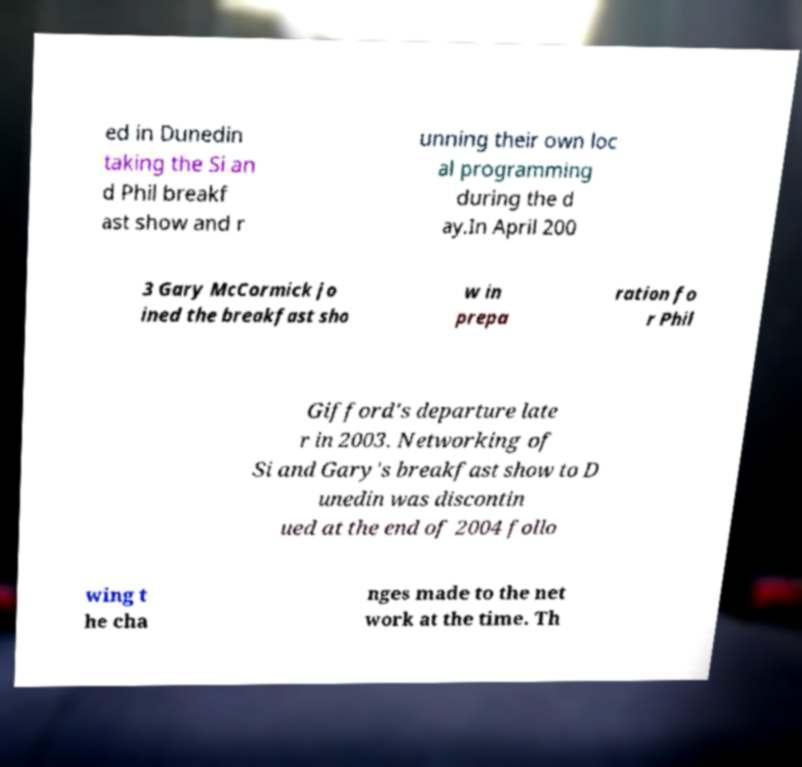What messages or text are displayed in this image? I need them in a readable, typed format. ed in Dunedin taking the Si an d Phil breakf ast show and r unning their own loc al programming during the d ay.In April 200 3 Gary McCormick jo ined the breakfast sho w in prepa ration fo r Phil Gifford's departure late r in 2003. Networking of Si and Gary's breakfast show to D unedin was discontin ued at the end of 2004 follo wing t he cha nges made to the net work at the time. Th 